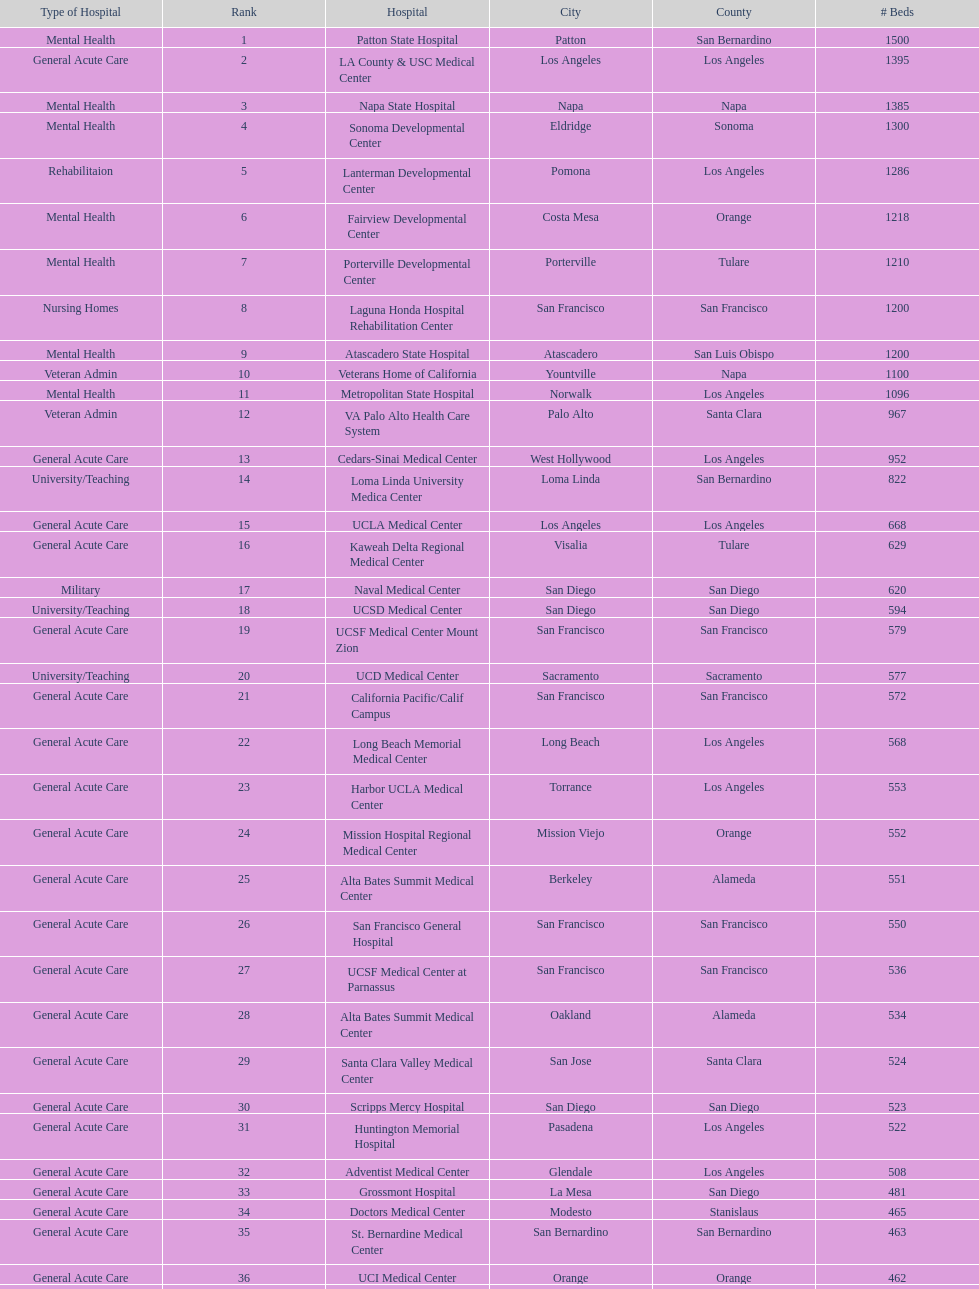How many hospital's have at least 600 beds? 17. 